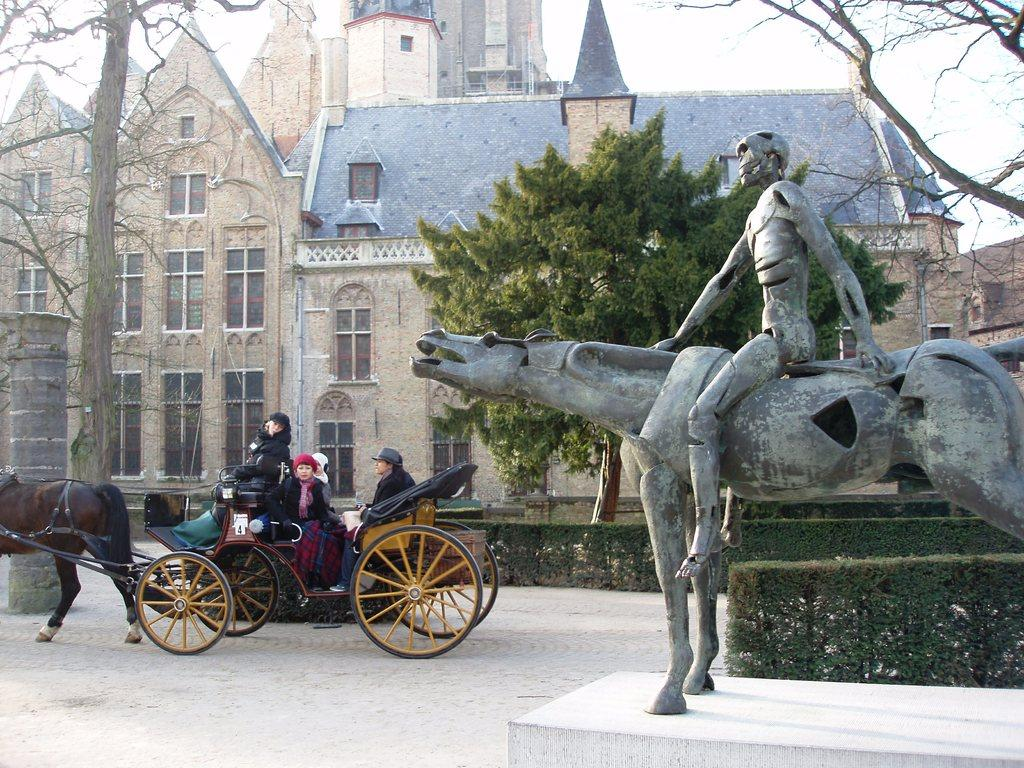What can be seen on the right side of the image? There is a statue on the right side of the image. What is happening on the left side of the image? There are people on a horse cart on the left side of the image. What type of environment is depicted in the background of the image? There are trees and buildings in the background of the image. What type of lock can be seen securing the horse cart in the image? There is no lock visible in the image; the horse cart is not secured with a lock. What type of farm animals can be seen in the scene? There are no farm animals present in the image. 